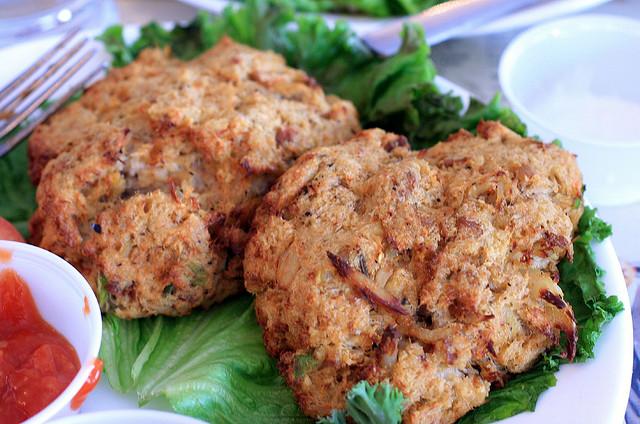What is underneath the breaded pieces of food?
Write a very short answer. Lettuce. What food is in the plastic cup?
Answer briefly. Cocktail sauce. What is mainly featured?
Answer briefly. Crab cakes. 